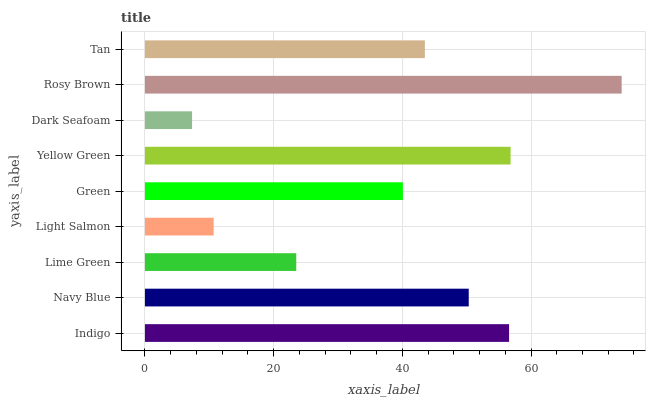Is Dark Seafoam the minimum?
Answer yes or no. Yes. Is Rosy Brown the maximum?
Answer yes or no. Yes. Is Navy Blue the minimum?
Answer yes or no. No. Is Navy Blue the maximum?
Answer yes or no. No. Is Indigo greater than Navy Blue?
Answer yes or no. Yes. Is Navy Blue less than Indigo?
Answer yes or no. Yes. Is Navy Blue greater than Indigo?
Answer yes or no. No. Is Indigo less than Navy Blue?
Answer yes or no. No. Is Tan the high median?
Answer yes or no. Yes. Is Tan the low median?
Answer yes or no. Yes. Is Yellow Green the high median?
Answer yes or no. No. Is Navy Blue the low median?
Answer yes or no. No. 